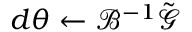Convert formula to latex. <formula><loc_0><loc_0><loc_500><loc_500>d { \theta } \gets \mathcal { B } ^ { - 1 } \tilde { \mathcal { G } }</formula> 